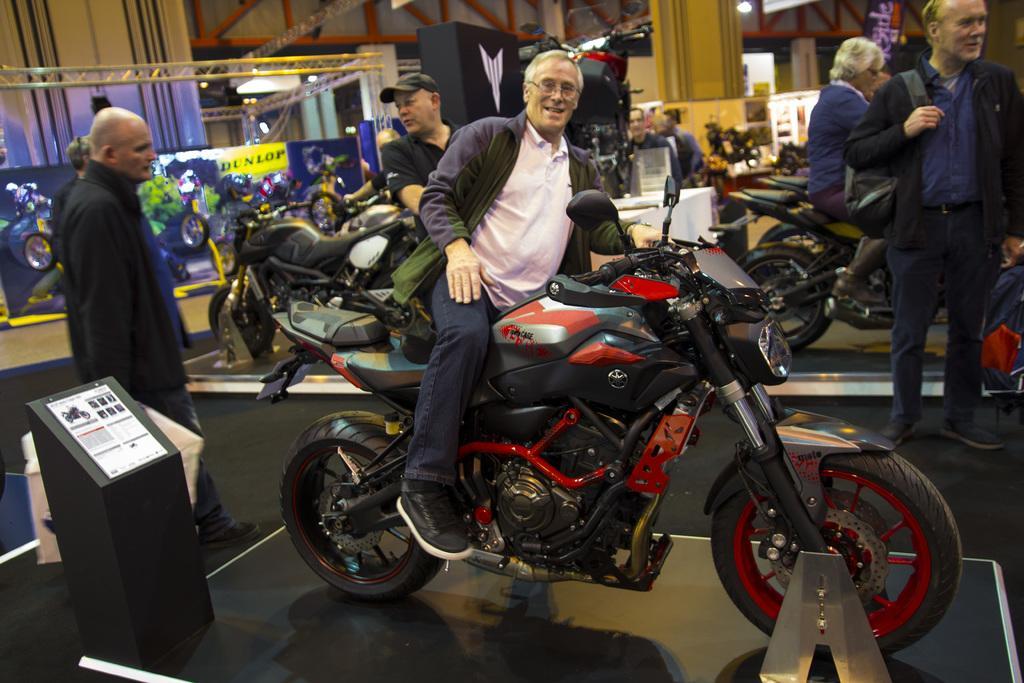Could you give a brief overview of what you see in this image? This picture shows a man on the bike and few people standing on the side 